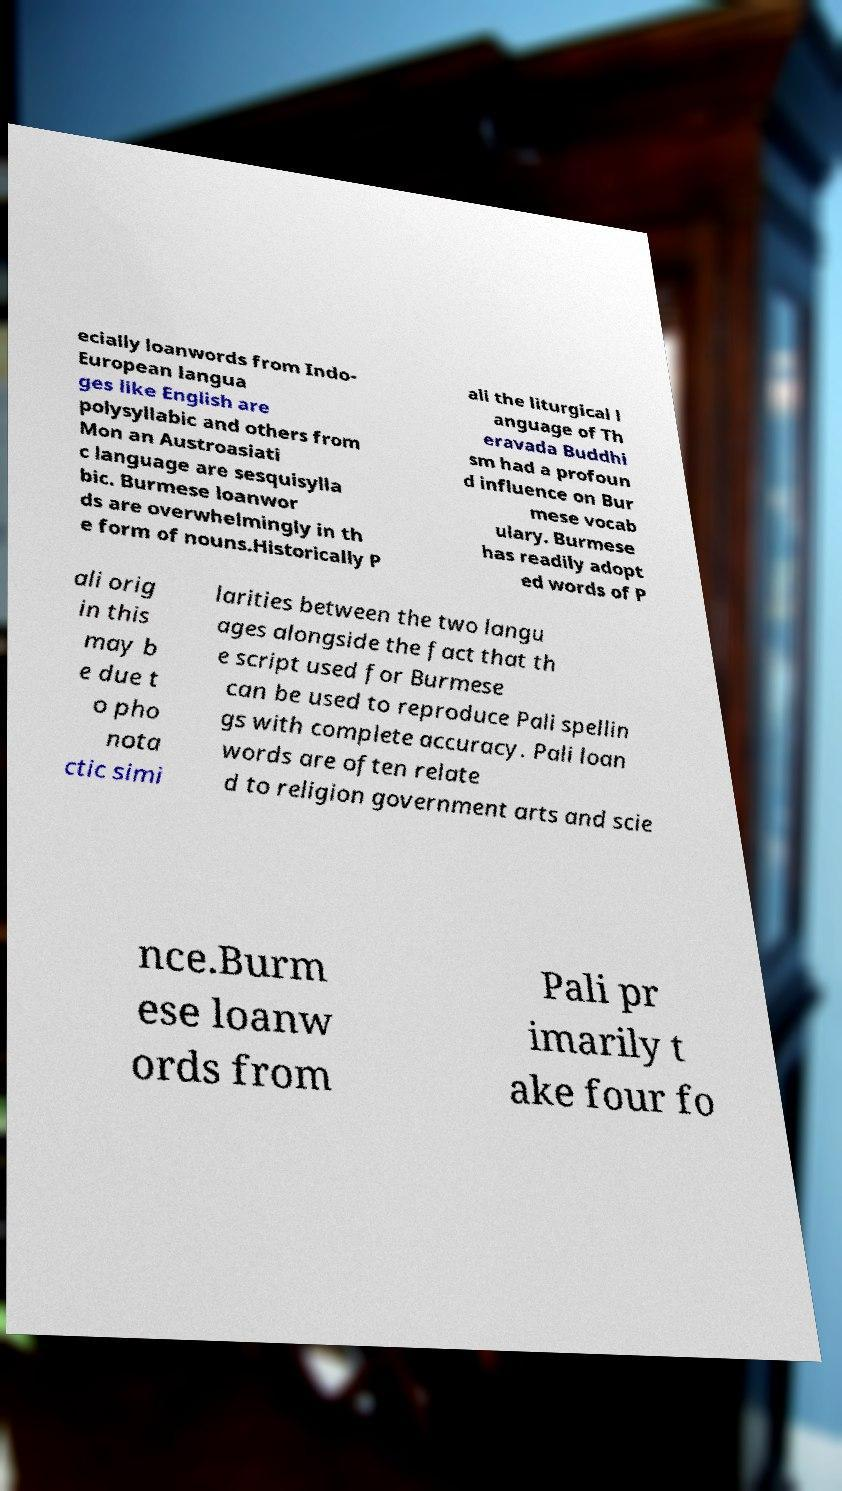I need the written content from this picture converted into text. Can you do that? ecially loanwords from Indo- European langua ges like English are polysyllabic and others from Mon an Austroasiati c language are sesquisylla bic. Burmese loanwor ds are overwhelmingly in th e form of nouns.Historically P ali the liturgical l anguage of Th eravada Buddhi sm had a profoun d influence on Bur mese vocab ulary. Burmese has readily adopt ed words of P ali orig in this may b e due t o pho nota ctic simi larities between the two langu ages alongside the fact that th e script used for Burmese can be used to reproduce Pali spellin gs with complete accuracy. Pali loan words are often relate d to religion government arts and scie nce.Burm ese loanw ords from Pali pr imarily t ake four fo 